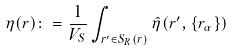Convert formula to latex. <formula><loc_0><loc_0><loc_500><loc_500>\eta ( { r } ) \colon = \frac { 1 } { V _ { S } } \int _ { { r ^ { \prime } } \in S _ { R } ( { r } ) } \hat { \eta } ( { r ^ { \prime } } , \{ { r } _ { \alpha } \} )</formula> 